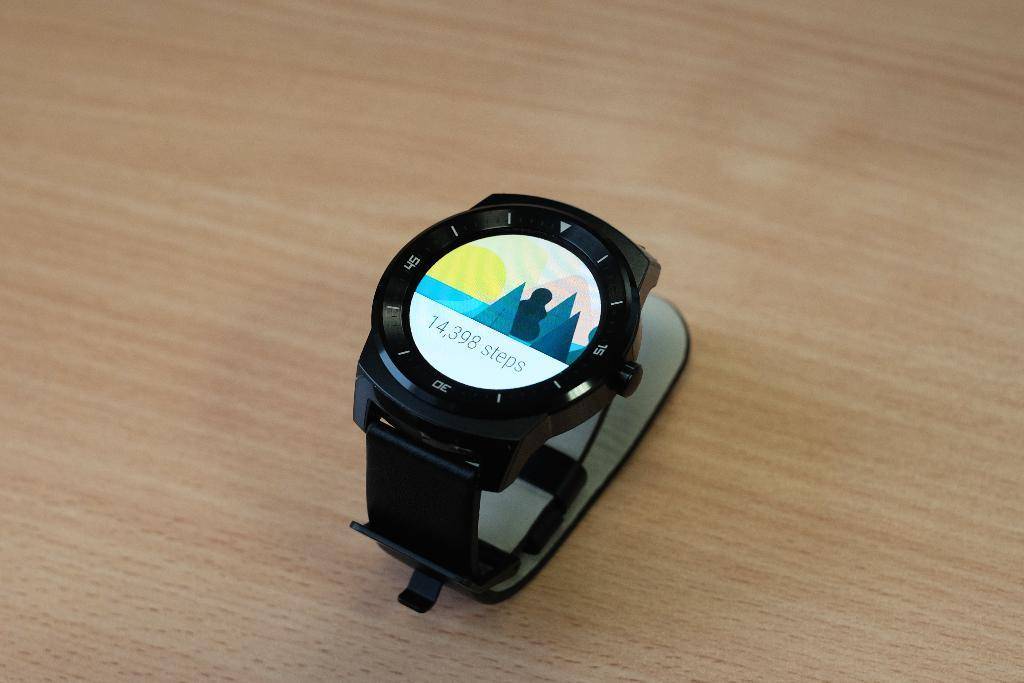<image>
Give a short and clear explanation of the subsequent image. A watch that says 14,398 steps sits on top of a wooden surface 